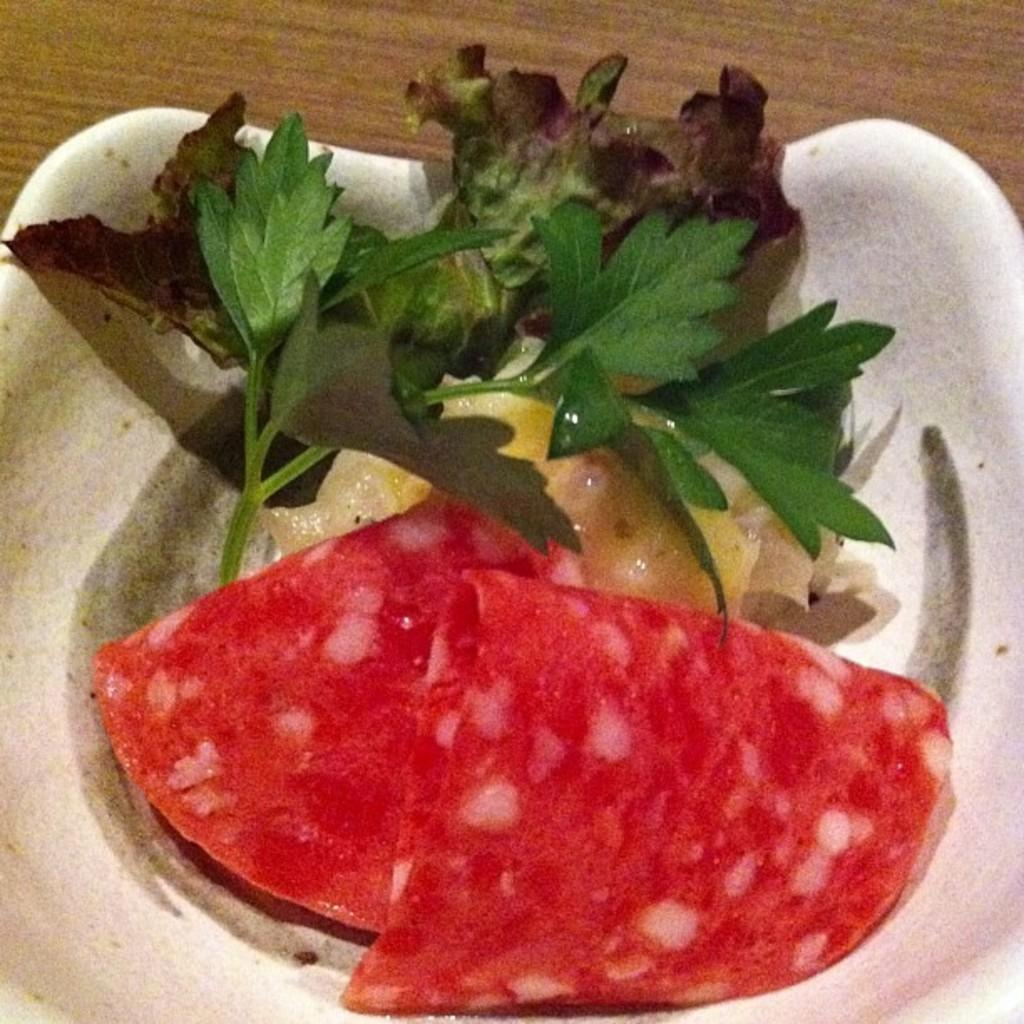What is in the bowl that is visible in the image? The bowl contains food. Where is the bowl located in the image? The bowl is placed on a table. Are there any visible cobwebs in the image? There is no mention of cobwebs in the provided facts, and therefore it cannot be determined if any are present in the image. 